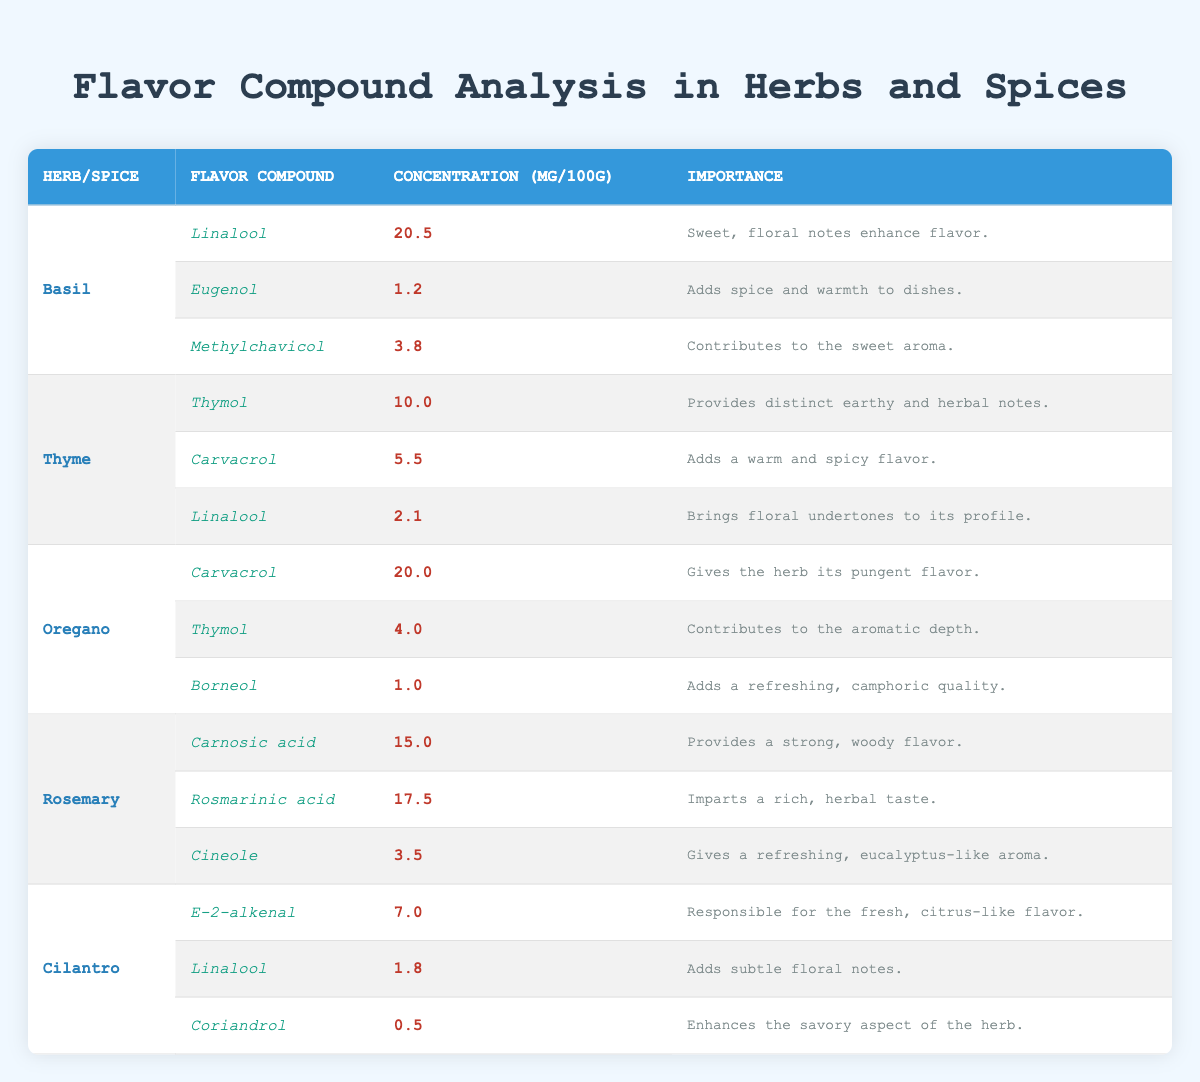What are the flavor compounds found in Basil? The table lists three flavor compounds for Basil: Linalool, Eugenol, and Methylchavicol.
Answer: Linalool, Eugenol, Methylchavicol Which herb contains the highest concentration of Linalool? By comparing the concentrations of Linalool across all herbs, Basil has 20.5 mg per 100g, which is higher than any other herb listed.
Answer: Basil Is Thymol present in Oregano? The table shows Thymol listed as a flavor compound for both Thyme and Oregano but does not specify its concentration for Oregano, thus it is only present in Oregano.
Answer: Yes What is the total concentration of Carvacrol in Thyme and Oregano combined? The concentration of Carvacrol in Thyme is 5.5 mg per 100g and in Oregano, it is 20.0 mg per 100g. Adding these values gives: 5.5 + 20.0 = 25.5 mg per 100g.
Answer: 25.5 Which herb has the lowest concentration of any listed flavor compound? Looking through the table, Cilantro has Coriandrol with the lowest concentration recorded at 0.5 mg per 100g.
Answer: Cilantro Does Rosemary contain any compounds that are also present in other herbs? Analyzing the table, both Rosmarinic acid and Cineole appear only in Rosemary, while Thymol and Carvacrol are shared with other herbs.
Answer: Yes What is the median concentration of flavor compounds in Oregano? The flavor compounds in Oregano have concentrations of 20.0, 4.0, and 1.0 mg per 100g. Arranging these values gives: 1.0, 4.0, 20.0. The median (middle value) is 4.0 mg per 100g.
Answer: 4.0 Which herb has the greatest variety of flavor compounds according to the table? The table shows Basil, Thyme, Oregano, Rosemary, and Cilantro, each with three flavor compounds listed. All have the same number of varieties, so there's no herb with greater variety.
Answer: All have the same variety What compound in Cilantro is responsible for its fresh, citrus-like flavor? The table specifies that the flavor compound responsible for the fresh, citrus-like flavor in Cilantro is E-2-alkenal.
Answer: E-2-alkenal Is the total concentration of flavor compounds in Basil greater than that in Cilantro? Basil's total concentrations for its flavor compounds are: 20.5 (Linalool) + 1.2 (Eugenol) + 3.8 (Methylchavicol) = 25.5 mg. Cilantro totals: 7.0 (E-2-alkenal) + 1.8 (Linalool) + 0.5 (Coriandrol) = 9.3 mg. Therefore, 25.5 mg is greater than 9.3 mg.
Answer: Yes 